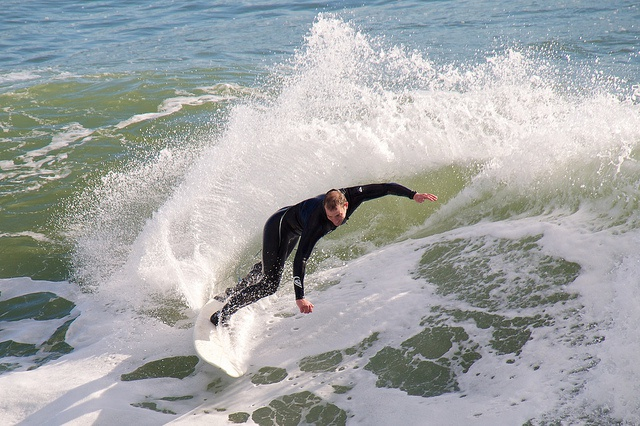Describe the objects in this image and their specific colors. I can see people in gray, black, darkgray, and brown tones and surfboard in gray, white, darkgray, and lightgray tones in this image. 